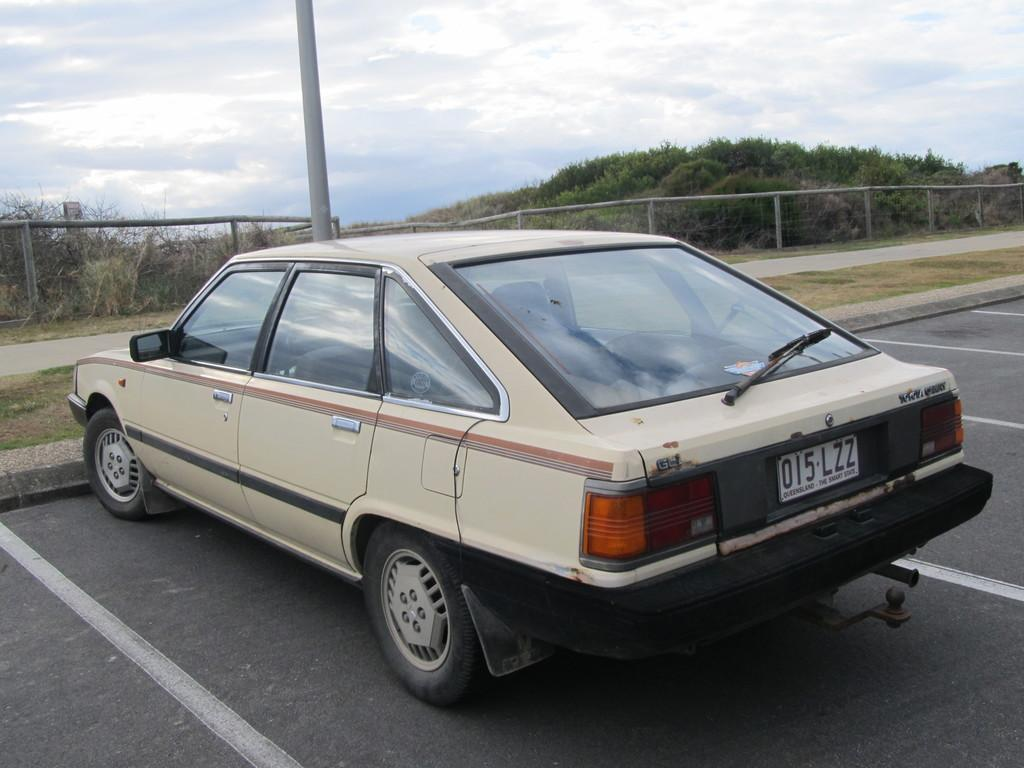What is the main subject of the image? There is a car on the road in the image. What can be seen in the background of the image? There is an iron pole, a fence, trees, and the sky visible in the background of the image. What emotion does the car display in the image? Cars do not have emotions, so this question cannot be answered. 